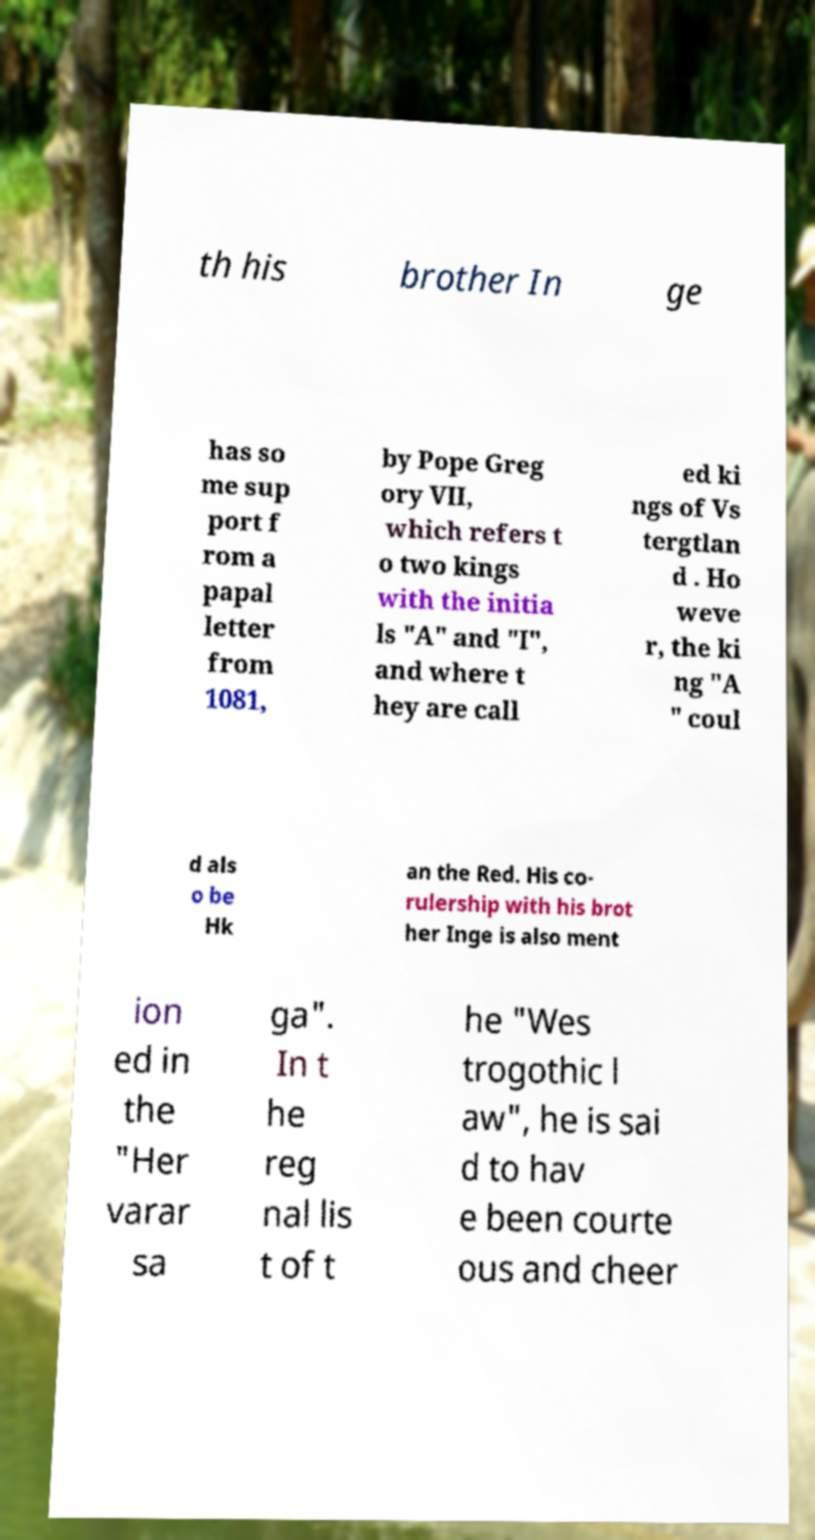Could you assist in decoding the text presented in this image and type it out clearly? th his brother In ge has so me sup port f rom a papal letter from 1081, by Pope Greg ory VII, which refers t o two kings with the initia ls "A" and "I", and where t hey are call ed ki ngs of Vs tergtlan d . Ho weve r, the ki ng "A " coul d als o be Hk an the Red. His co- rulership with his brot her Inge is also ment ion ed in the "Her varar sa ga". In t he reg nal lis t of t he "Wes trogothic l aw", he is sai d to hav e been courte ous and cheer 